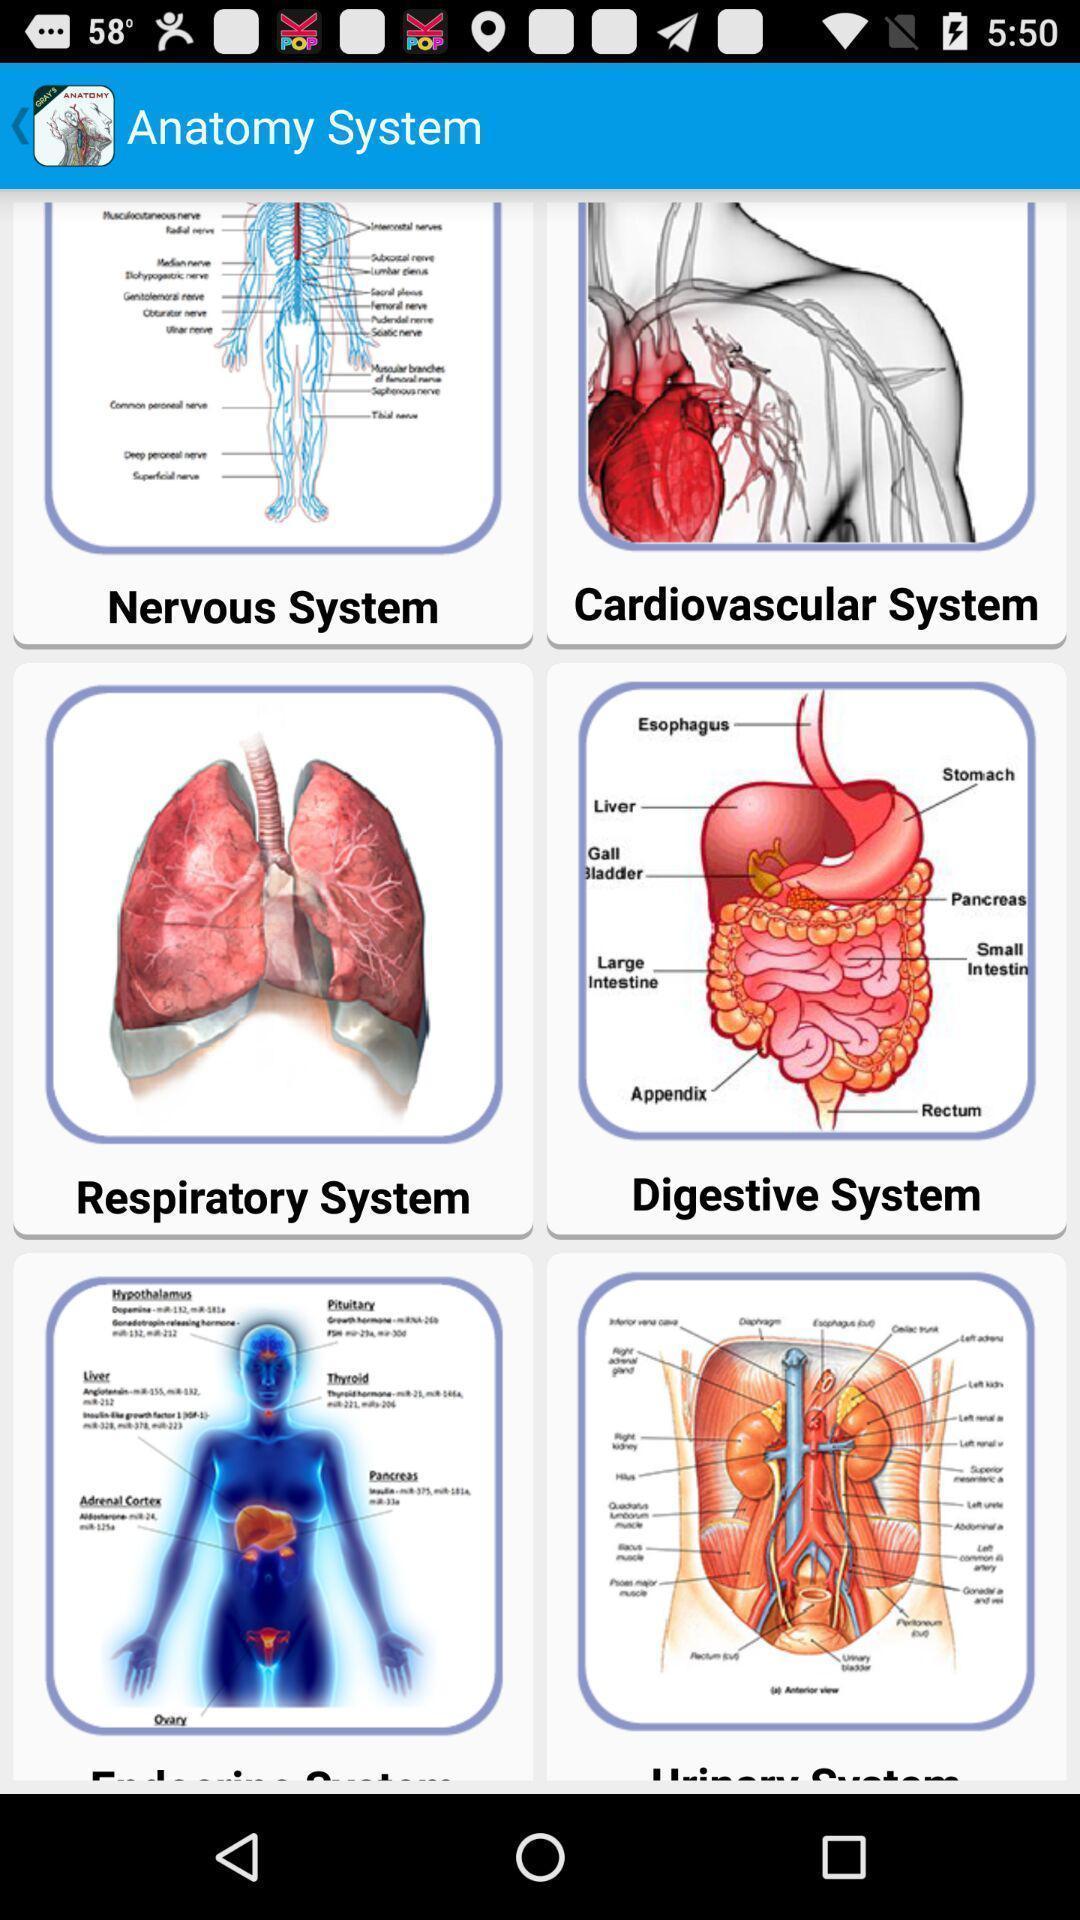Please provide a description for this image. Page showing about human anatomy. 